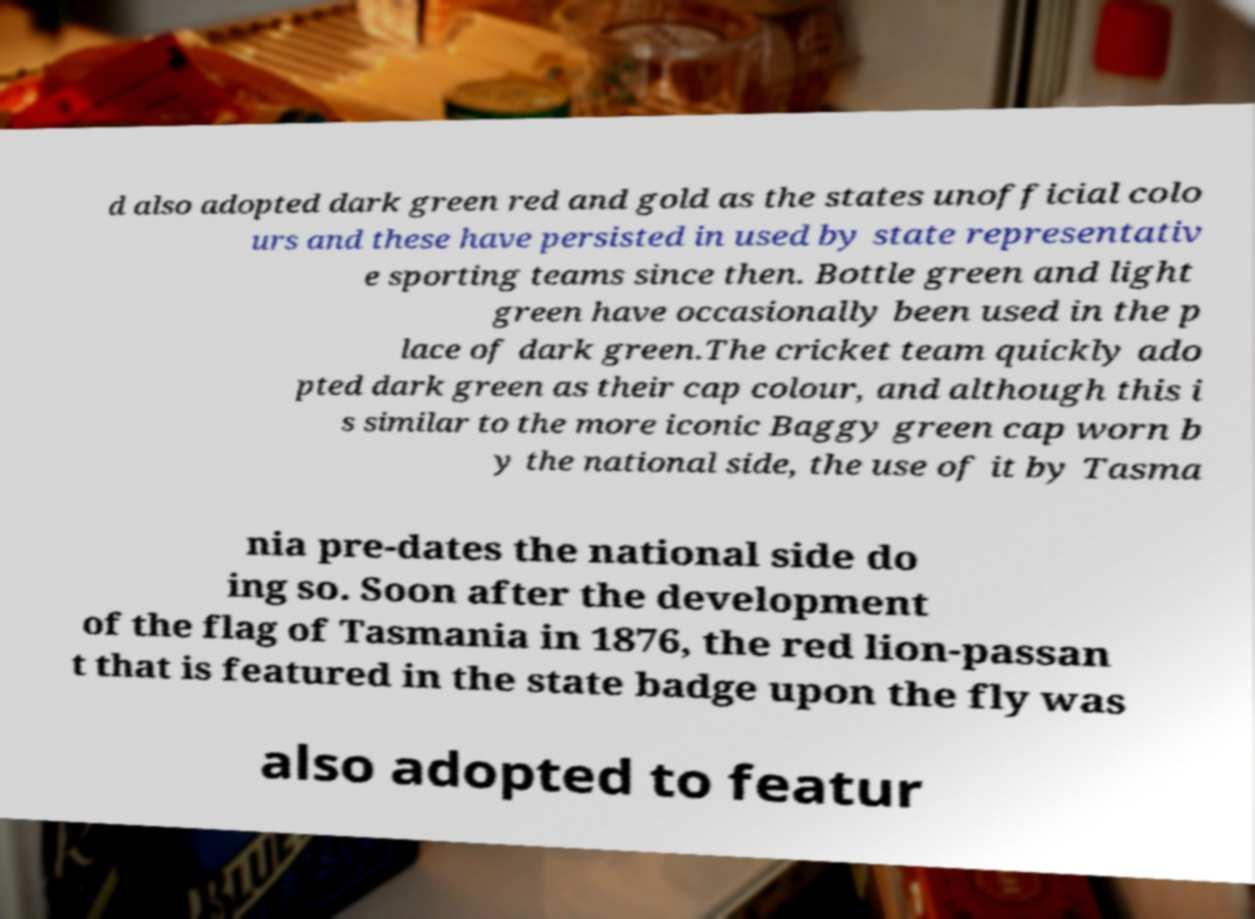What messages or text are displayed in this image? I need them in a readable, typed format. d also adopted dark green red and gold as the states unofficial colo urs and these have persisted in used by state representativ e sporting teams since then. Bottle green and light green have occasionally been used in the p lace of dark green.The cricket team quickly ado pted dark green as their cap colour, and although this i s similar to the more iconic Baggy green cap worn b y the national side, the use of it by Tasma nia pre-dates the national side do ing so. Soon after the development of the flag of Tasmania in 1876, the red lion-passan t that is featured in the state badge upon the fly was also adopted to featur 